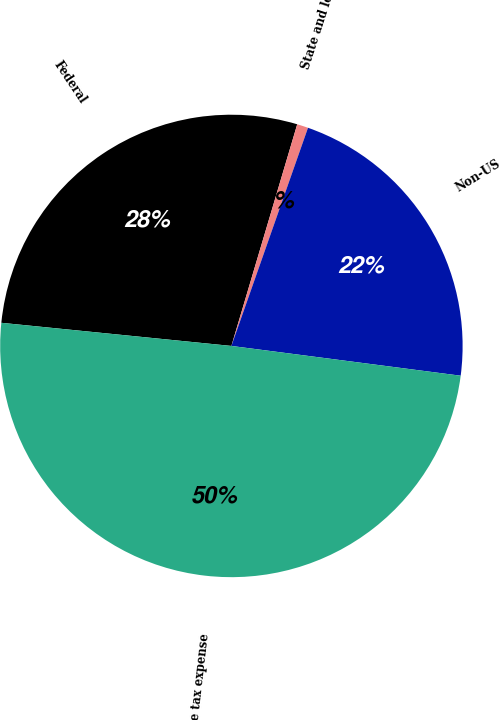Convert chart to OTSL. <chart><loc_0><loc_0><loc_500><loc_500><pie_chart><fcel>Federal<fcel>State and local<fcel>Non-US<fcel>Income tax expense<nl><fcel>28.0%<fcel>0.78%<fcel>21.68%<fcel>49.54%<nl></chart> 